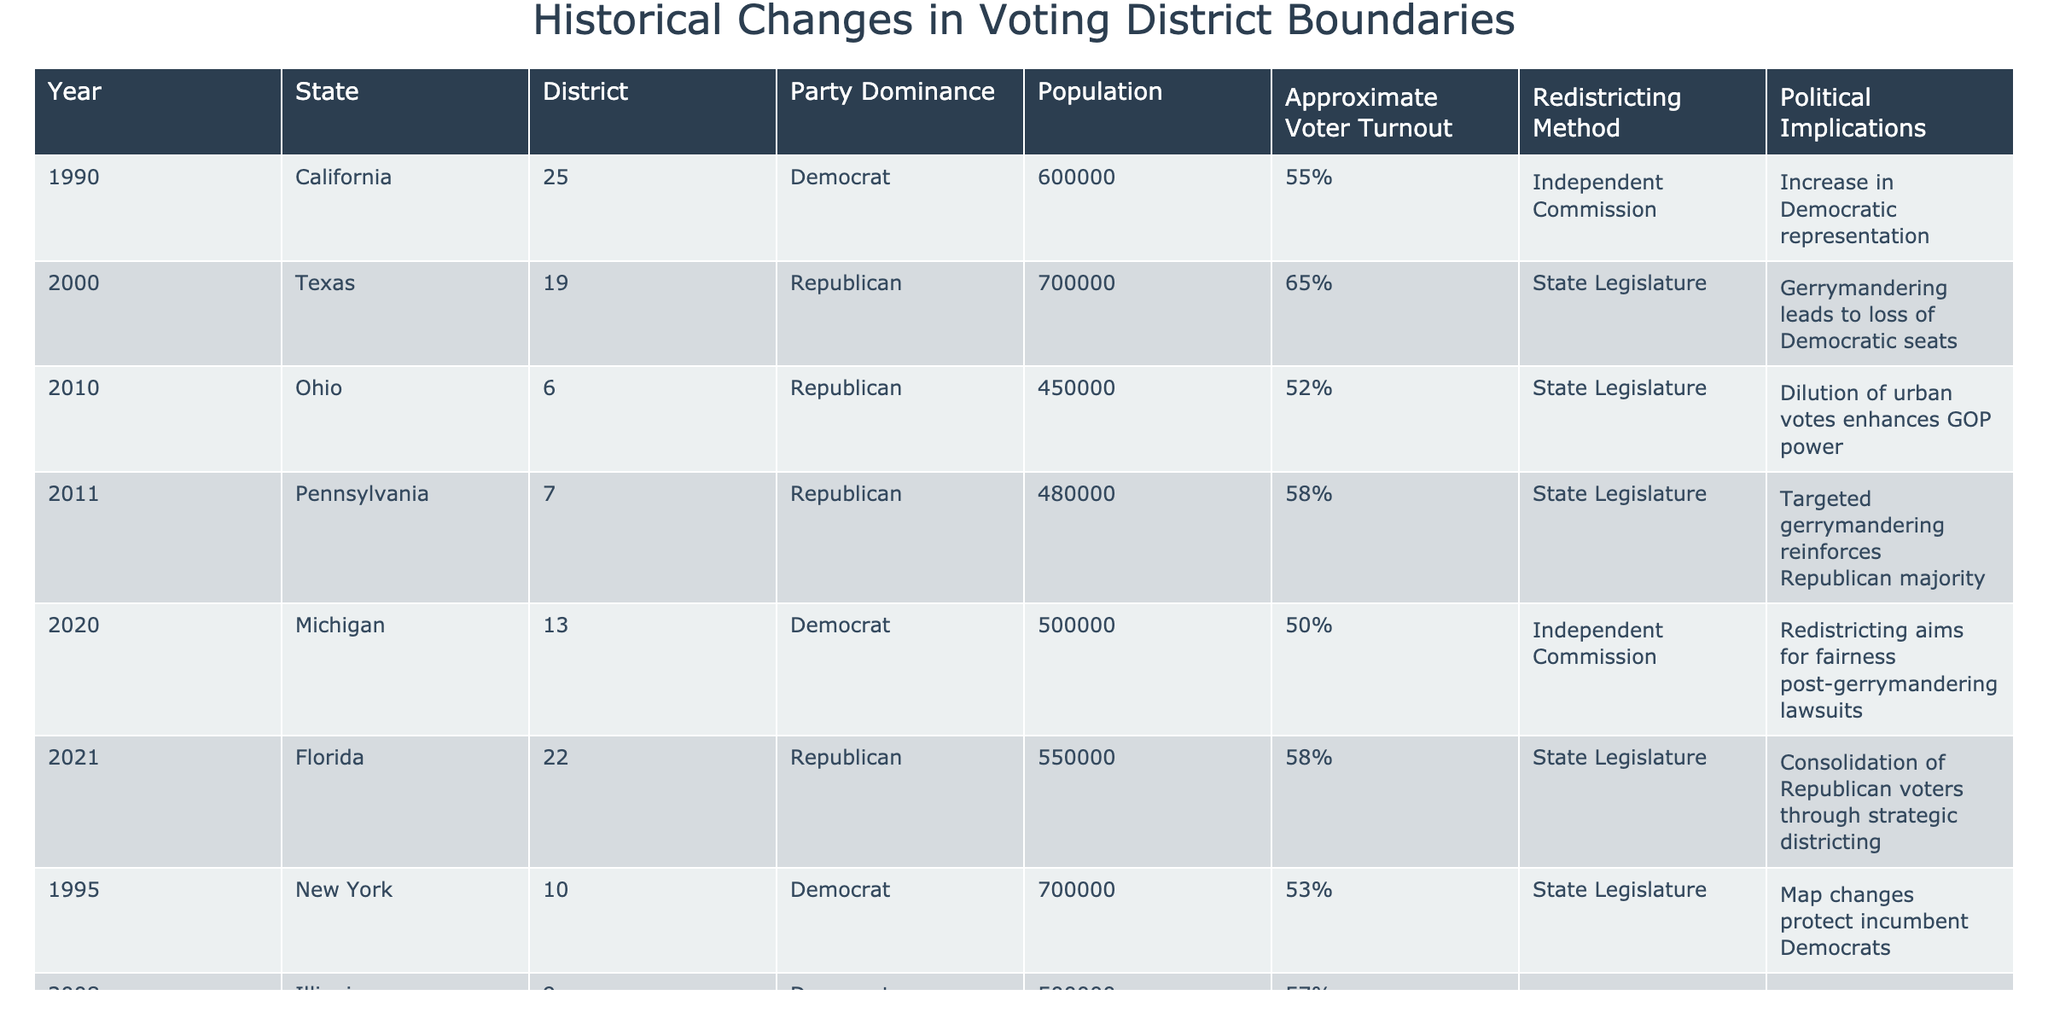What year did independent commissions first appear in the table? The only years listed with independent commissions are 1990 (California) and 2020 (Michigan). The earliest instance appears in 1990.
Answer: 1990 Which state had the highest population in a district during the recorded years? The state with the highest population in a district is Texas with 700,000 in the year 2000.
Answer: Texas, 700,000 How many states used a state legislature for redistricting after 2010? The states that used state legislatures for redistricting after 2010 are Ohio (2010), Pennsylvania (2011), Florida (2021), and Wisconsin (2018). This totals four instances.
Answer: 4 Did all states with districts represented by Democrats show an increase in Democrat representation? According to the table, California (1990) noted an increase in Democratic representation, but Illinois (2008) indicates a negative impact for the GOP; hence not all states show uniform trends.
Answer: No What is the average approximate voter turnout for districts listed in the table? To find the average, we sum the voter turnout percentages: (55 + 65 + 52 + 58 + 50 + 58 + 53 + 57 + 60 + 54) =  576 and divide by the number of entries (10), resulting in an average of 57.6%.
Answer: 57.6% Which party dominated the majority of the districts in the table? Reviewing the table, there are more Republican-dominated instances (6) than Democrat (4).
Answer: Republican Was there a higher percentage of voter turnout in districts dominated by Replicans or Democrats? By comparing the average percentages, we find that Republican dominance (average 56.2%) is higher than Democratic dominance (average 55.2%).
Answer: Republicans Which district in 2018 experienced a political implication related to a high court ruling? The district in Wisconsin (5th) in 2018 stated that a high court ruling on partisan gerrymandering impacted future elections.
Answer: Wisconsin, 2018 How does the population size in the Texas district from 2000 compare to the Ohio district in 2010? The Texas district had a population of 700,000, while the Ohio district had a population of 450,000; thus, Texas had 250,000 more.
Answer: 250,000 more in Texas What trend is noted in Michigan’s 2020 redistricting? The redistricting process in Michigan aimed for fairness due to previous gerrymandering lawsuits, indicating a move towards equitable district boundaries.
Answer: Fairness post-gerrymandering How many instances of targeted gerrymandering are mentioned in the table? The table indicates three instances of targeted gerrymandering: Pennsylvania (2011), Ohio (2010), and North Carolina (1985)
Answer: 3 